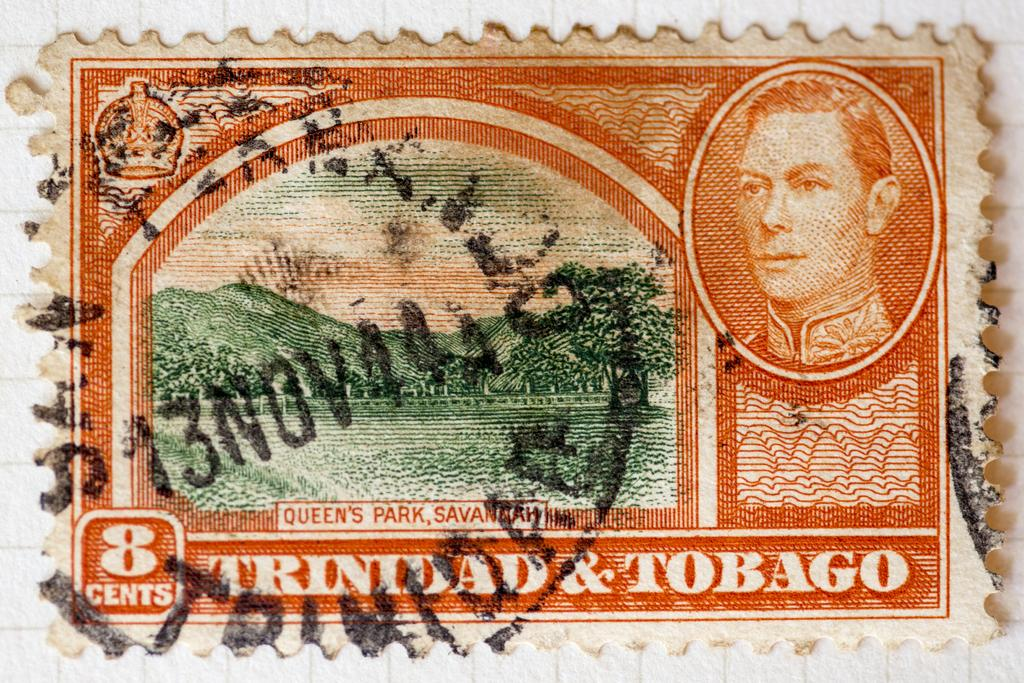What is the main subject of the image? The main subject of the image is a stamp. What can be seen on the stamp? The stamp has images of hills, trees, and a man. Where is the stamp located? The stamp is on a surface. Is there any text on the stamp? Yes, there is writing on the stamp. How many chairs are visible in the image? There are no chairs present in the image; it features a stamp with images of hills, trees, and a man. Is there a gate visible in the image? There is no gate present in the image; it features a stamp with images of hills, trees, and a man. 